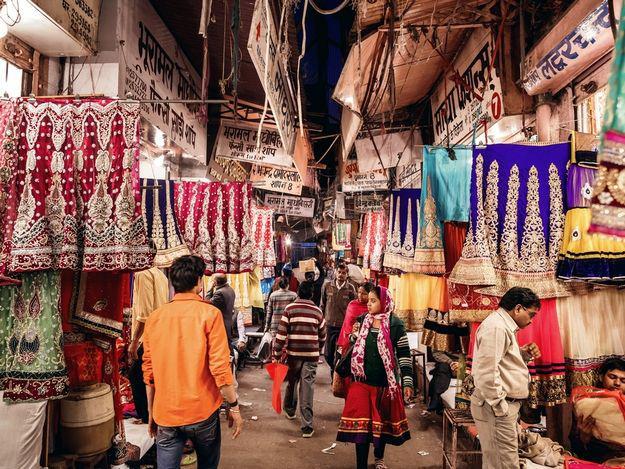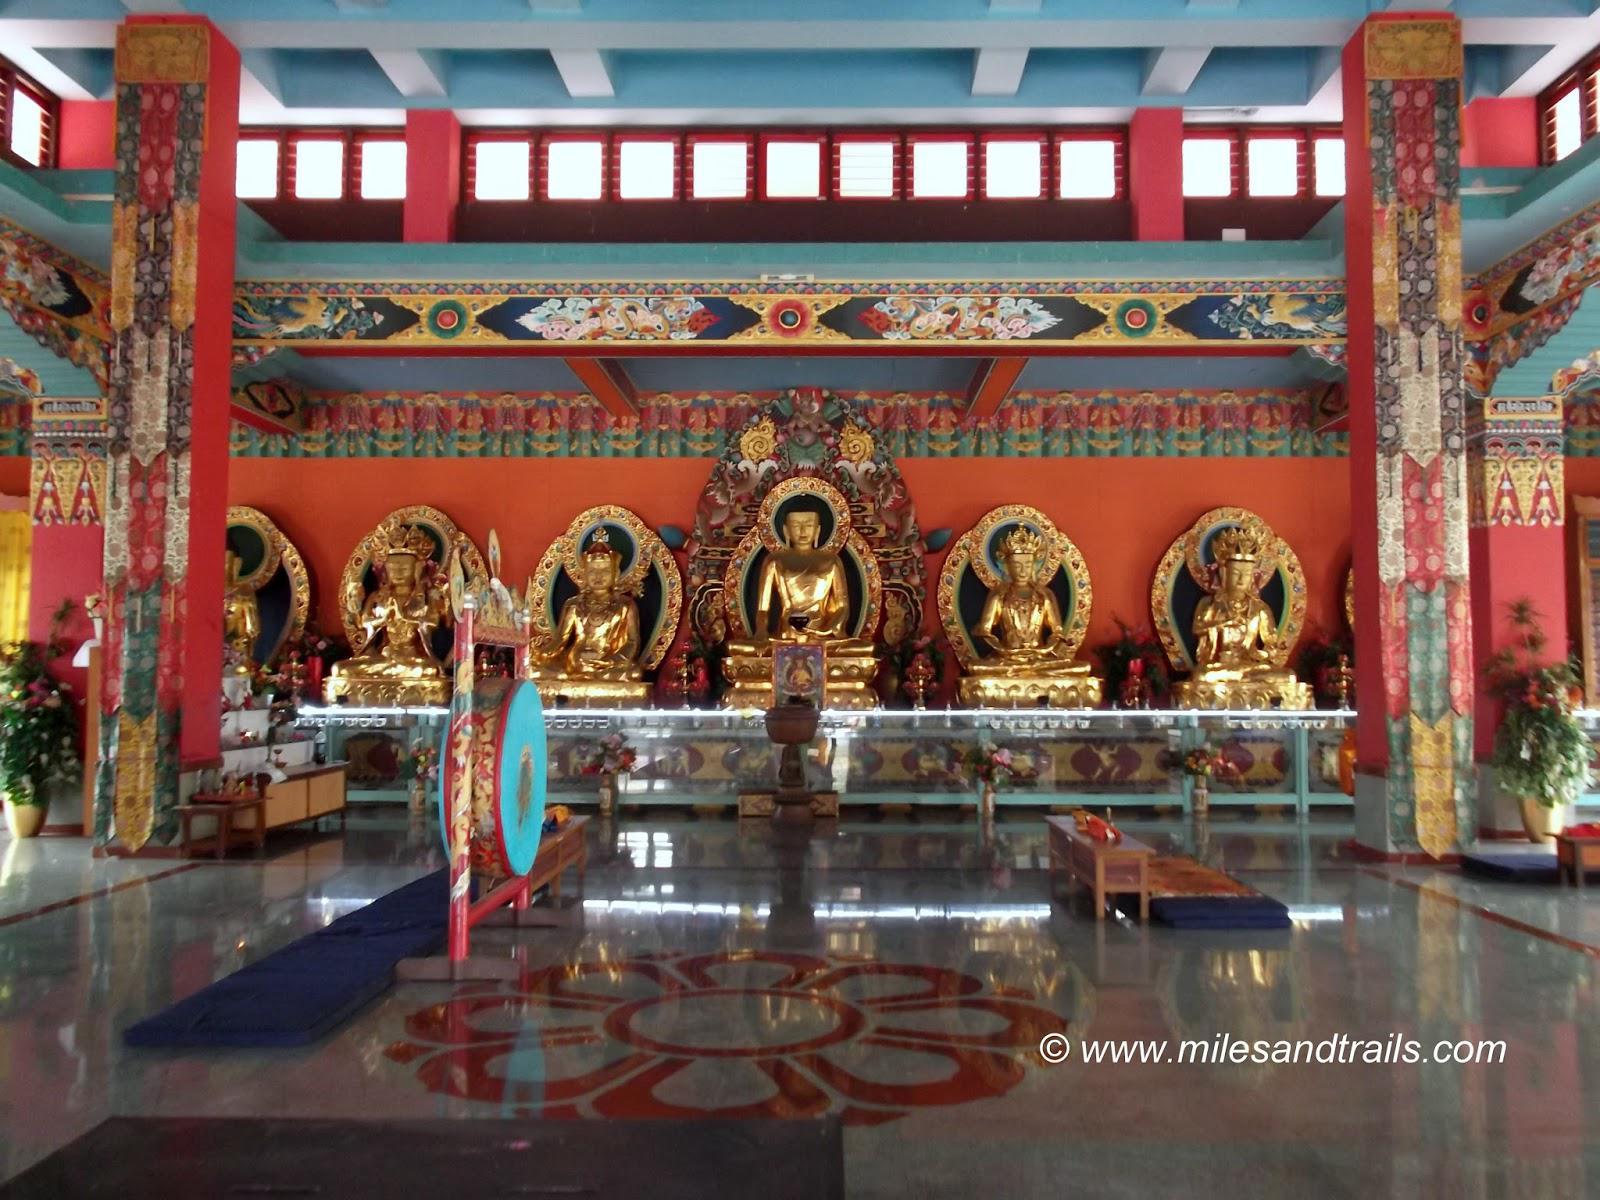The first image is the image on the left, the second image is the image on the right. Assess this claim about the two images: "The left and right image contains the same number of monasteries.". Correct or not? Answer yes or no. No. The first image is the image on the left, the second image is the image on the right. For the images shown, is this caption "An image shows the exterior of a temple with bold, decorative symbols repeating across a white banner running the length of the building." true? Answer yes or no. No. 